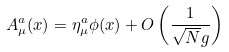Convert formula to latex. <formula><loc_0><loc_0><loc_500><loc_500>A _ { \mu } ^ { a } ( x ) = \eta ^ { a } _ { \mu } \phi ( x ) + O \left ( \frac { 1 } { \sqrt { N } g } \right )</formula> 